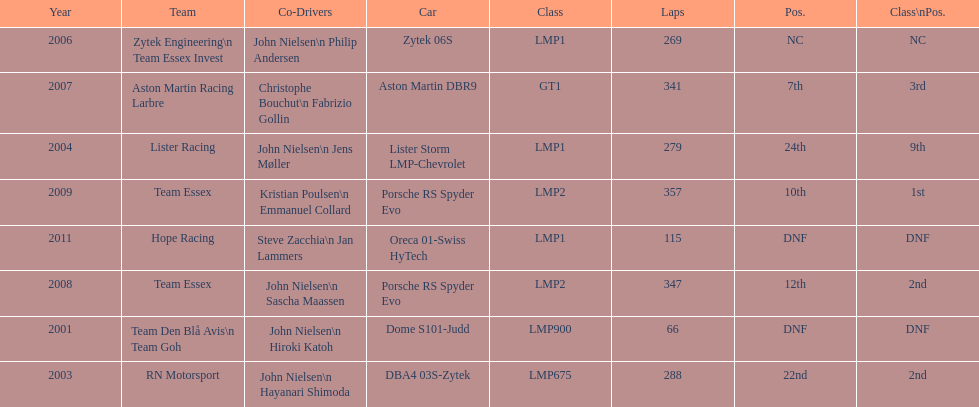How many times was the porsche rs spyder used in competition? 2. 